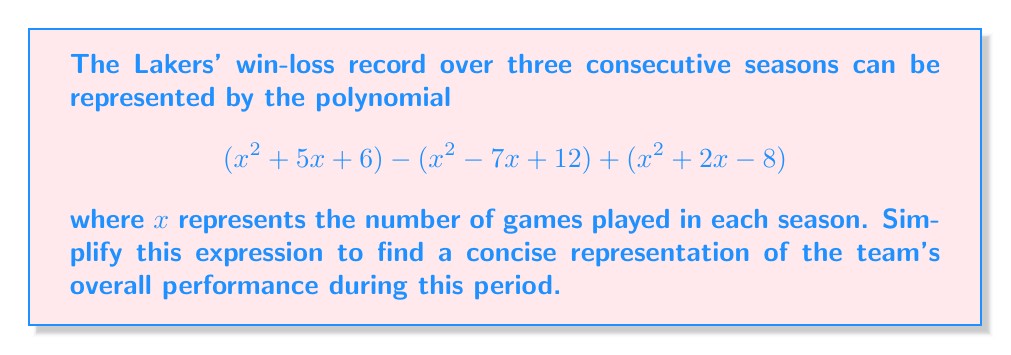What is the answer to this math problem? Let's approach this step-by-step:

1) First, we need to combine like terms. We have three $x^2$ terms, three $x$ terms, and three constant terms.

2) For the $x^2$ terms:
   $$(x^2) - (x^2) + (x^2) = x^2$$

3) For the $x$ terms:
   $$(5x) - (-7x) + (2x) = 5x + 7x + 2x = 14x$$

4) For the constant terms:
   $$(6) - (12) + (-8) = -14$$

5) Now, we can write our simplified polynomial:
   $$x^2 + 14x - 14$$

6) This polynomial can be factored further. Let's use the ac-method:
   - We need two numbers that multiply to give $ac = 1 \times (-14) = -14$ and add up to $b = 14$
   - These numbers are 16 and -2

7) Rewrite the middle term:
   $$x^2 + 16x - 2x - 14$$

8) Factor by grouping:
   $$(x^2 + 16x) + (-2x - 14)$$
   $$x(x + 16) - 2(x + 7)$$
   $$(x - 2)(x + 7)$$

This factored form represents the simplified polynomial depicting the Lakers' win-loss record over the three seasons.
Answer: $$(x - 2)(x + 7)$$ 